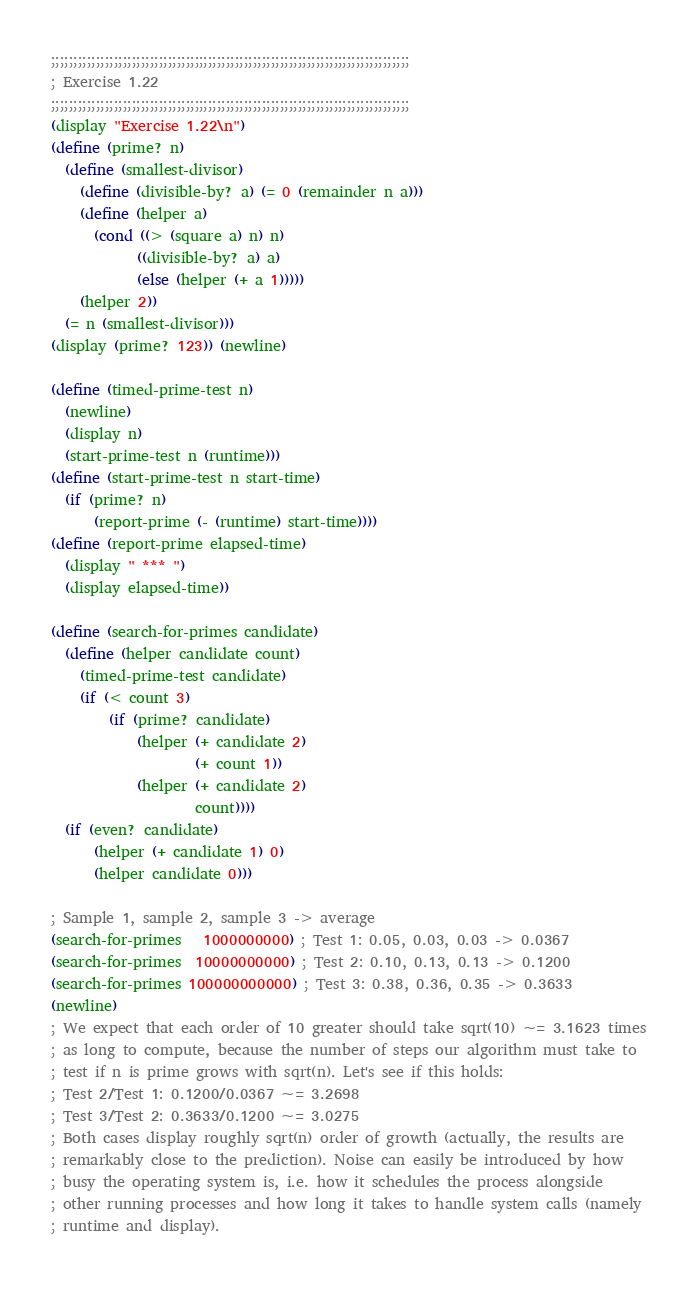<code> <loc_0><loc_0><loc_500><loc_500><_Scheme_>;;;;;;;;;;;;;;;;;;;;;;;;;;;;;;;;;;;;;;;;;;;;;;;;;;;;;;;;;;;;;;;;;;;;;;;;;;;;;;;;
; Exercise 1.22
;;;;;;;;;;;;;;;;;;;;;;;;;;;;;;;;;;;;;;;;;;;;;;;;;;;;;;;;;;;;;;;;;;;;;;;;;;;;;;;;
(display "Exercise 1.22\n")
(define (prime? n)
  (define (smallest-divisor)
    (define (divisible-by? a) (= 0 (remainder n a)))
    (define (helper a)
      (cond ((> (square a) n) n)
            ((divisible-by? a) a)
            (else (helper (+ a 1)))))
    (helper 2))
  (= n (smallest-divisor)))
(display (prime? 123)) (newline)

(define (timed-prime-test n)
  (newline)
  (display n)
  (start-prime-test n (runtime)))
(define (start-prime-test n start-time)
  (if (prime? n)
      (report-prime (- (runtime) start-time))))
(define (report-prime elapsed-time)
  (display " *** ")
  (display elapsed-time))

(define (search-for-primes candidate)
  (define (helper candidate count)
    (timed-prime-test candidate)
    (if (< count 3)
        (if (prime? candidate)
            (helper (+ candidate 2)
                    (+ count 1))
            (helper (+ candidate 2)
                    count))))
  (if (even? candidate)
      (helper (+ candidate 1) 0)
      (helper candidate 0)))

; Sample 1, sample 2, sample 3 -> average
(search-for-primes   1000000000) ; Test 1: 0.05, 0.03, 0.03 -> 0.0367
(search-for-primes  10000000000) ; Test 2: 0.10, 0.13, 0.13 -> 0.1200
(search-for-primes 100000000000) ; Test 3: 0.38, 0.36, 0.35 -> 0.3633
(newline)
; We expect that each order of 10 greater should take sqrt(10) ~= 3.1623 times
; as long to compute, because the number of steps our algorithm must take to
; test if n is prime grows with sqrt(n). Let's see if this holds:
; Test 2/Test 1: 0.1200/0.0367 ~= 3.2698
; Test 3/Test 2: 0.3633/0.1200 ~= 3.0275
; Both cases display roughly sqrt(n) order of growth (actually, the results are
; remarkably close to the prediction). Noise can easily be introduced by how
; busy the operating system is, i.e. how it schedules the process alongside
; other running processes and how long it takes to handle system calls (namely
; runtime and display).
</code> 